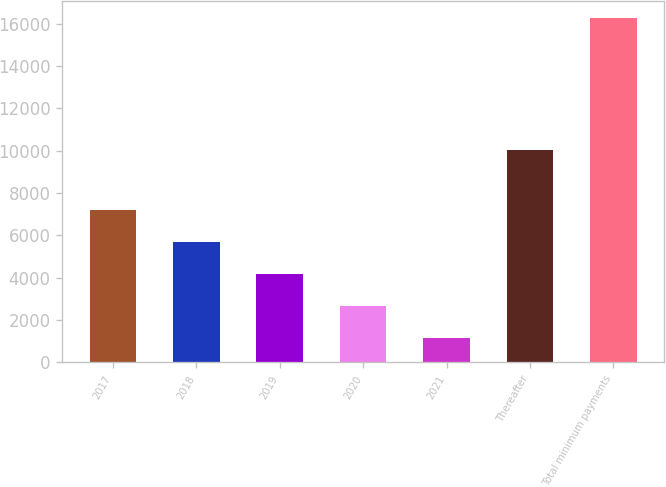Convert chart to OTSL. <chart><loc_0><loc_0><loc_500><loc_500><bar_chart><fcel>2017<fcel>2018<fcel>2019<fcel>2020<fcel>2021<fcel>Thereafter<fcel>Total minimum payments<nl><fcel>7211.14<fcel>5700.23<fcel>4189.32<fcel>2678.41<fcel>1167.5<fcel>10018.5<fcel>16276.6<nl></chart> 